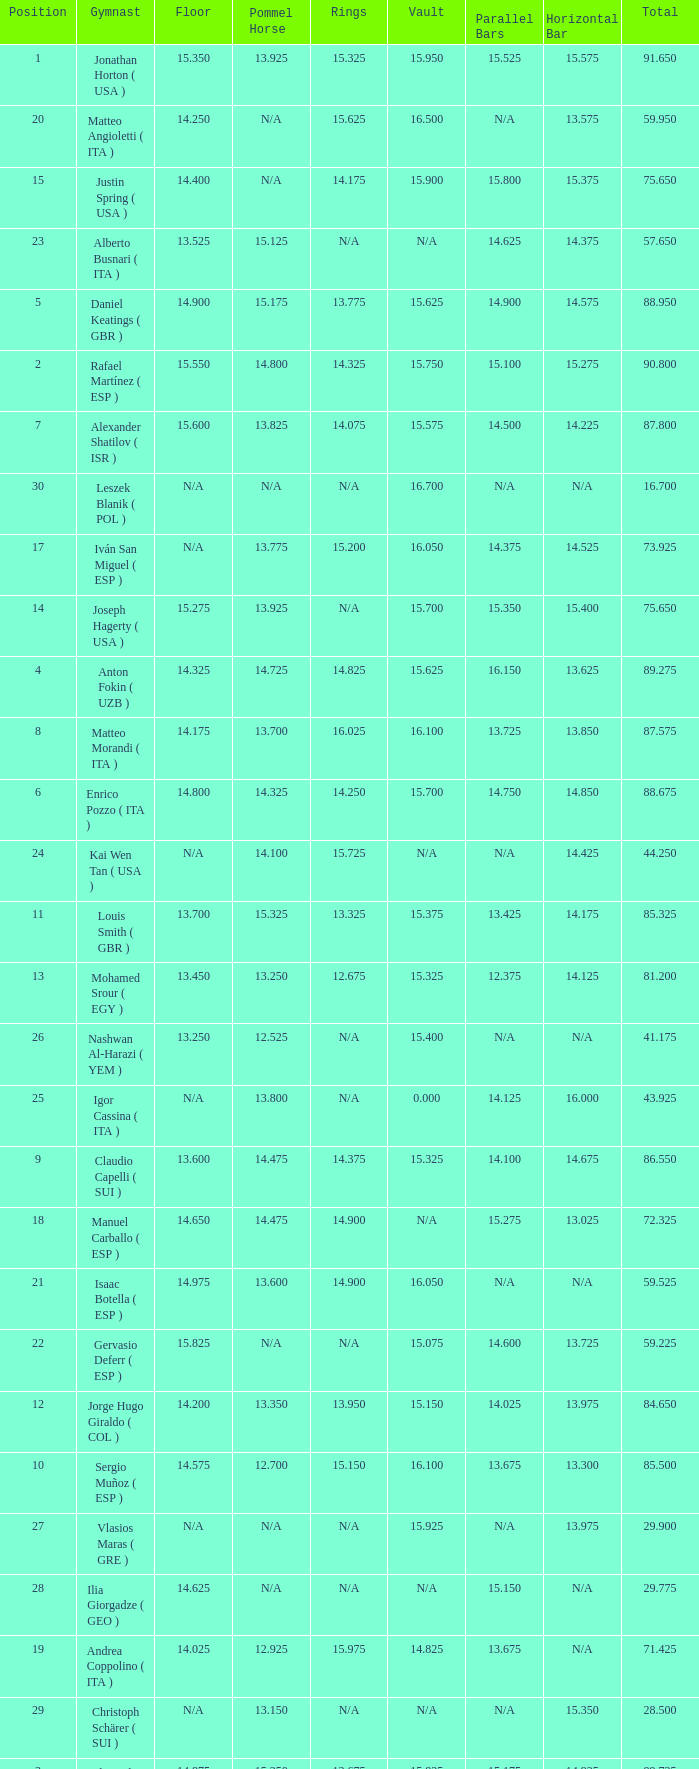If the floor number is 14.200, what is the number for the parallel bars? 14.025. 